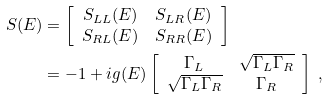<formula> <loc_0><loc_0><loc_500><loc_500>S ( E ) & = \left [ \begin{array} { c c } S _ { L L } ( E ) & S _ { L R } ( E ) \\ S _ { R L } ( E ) & S _ { R R } ( E ) \end{array} \right ] \\ & = - 1 + i g ( E ) \left [ \begin{array} { c c } \Gamma _ { L } & \sqrt { \Gamma _ { L } \Gamma _ { R } } \\ \sqrt { \Gamma _ { L } \Gamma _ { R } } & \Gamma _ { R } \end{array} \right ] \ ,</formula> 